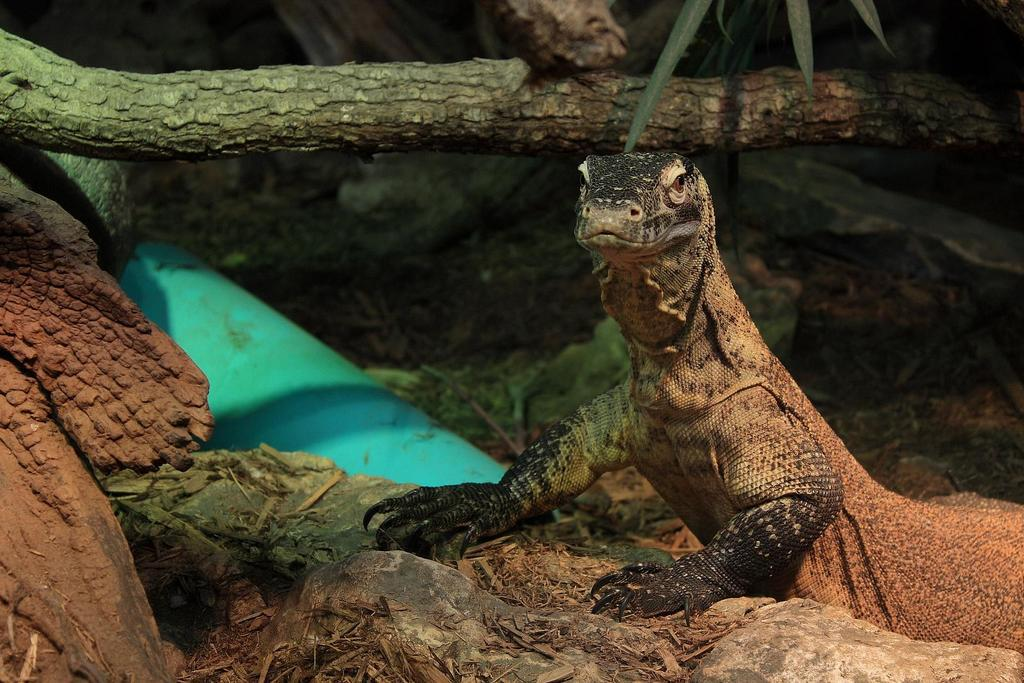What type of animal is in the image? There is a reptile in the image. What colors can be seen on the reptile? The reptile is black and brown in color. What natural elements are visible in the image? There are tree trunks and plants visible in the image. What is the color of the blue object in the image? There is a blue object in the image, but the specific color of the blue object is not mentioned in the facts. What type of bean is being served at the club in the image? There is no bean or club present in the image; it features a reptile, tree trunks, plants, and a blue object. 